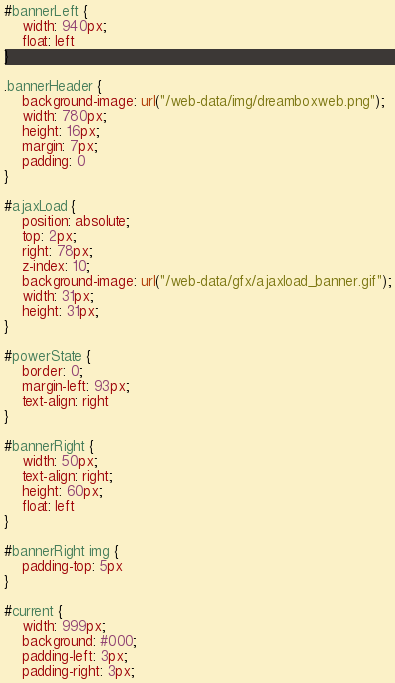Convert code to text. <code><loc_0><loc_0><loc_500><loc_500><_CSS_>
#bannerLeft {
	width: 940px;
	float: left
}

.bannerHeader {
	background-image: url("/web-data/img/dreamboxweb.png");
	width: 780px;
	height: 16px;
	margin: 7px;
	padding: 0
}

#ajaxLoad {
	position: absolute;
	top: 2px;
	right: 78px;
	z-index: 10;
	background-image: url("/web-data/gfx/ajaxload_banner.gif");
	width: 31px;
	height: 31px;
}

#powerState {
	border: 0;
	margin-left: 93px;
	text-align: right
}

#bannerRight {
	width: 50px;
	text-align: right;
	height: 60px;
	float: left
}

#bannerRight img {
	padding-top: 5px
}

#current {
	width: 999px;
	background: #000;
	padding-left: 3px;
	padding-right: 3px;</code> 